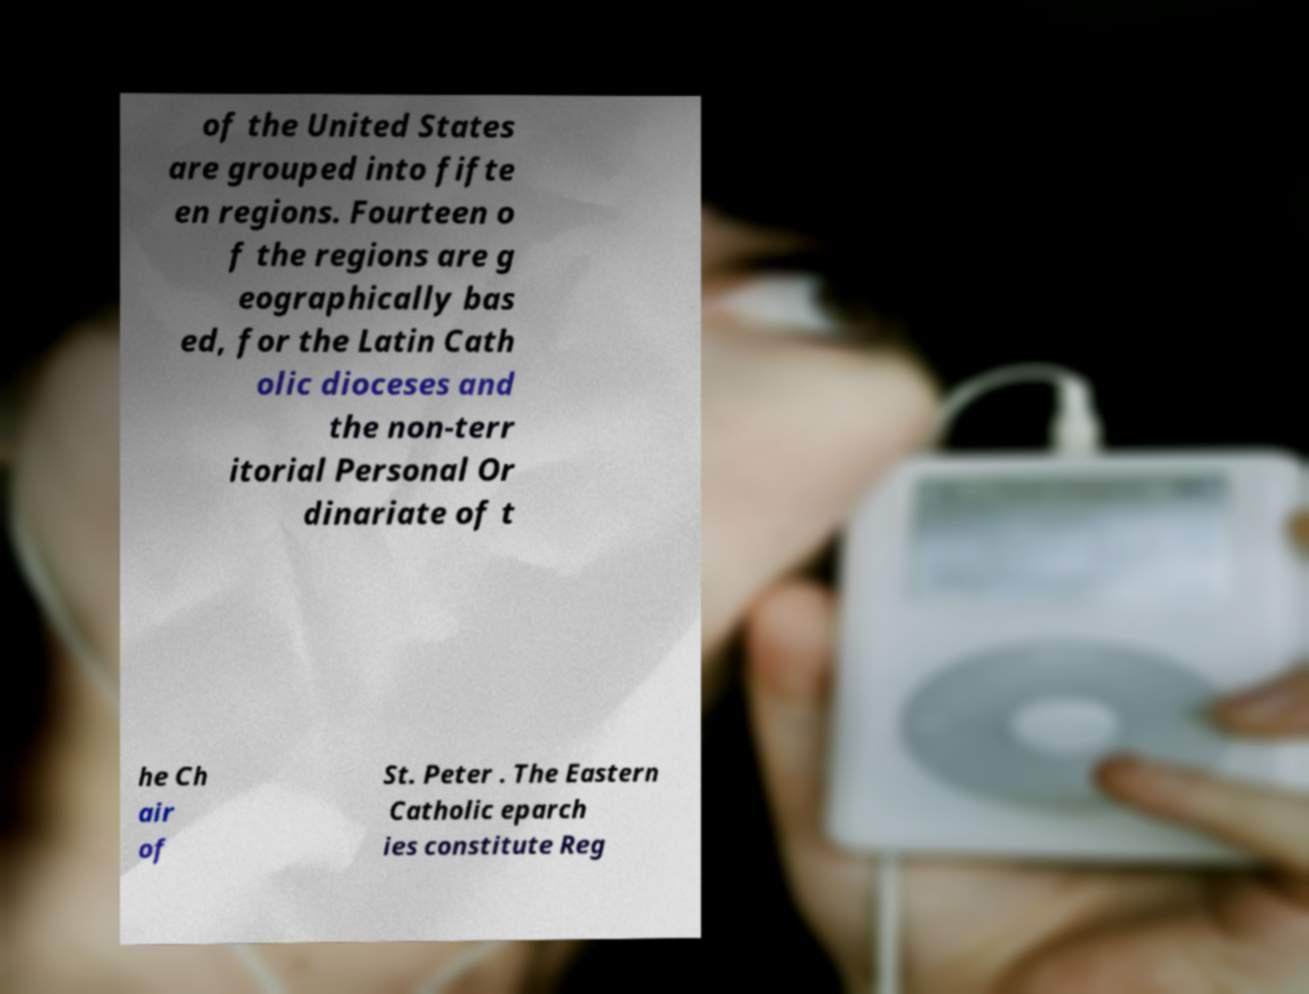What messages or text are displayed in this image? I need them in a readable, typed format. of the United States are grouped into fifte en regions. Fourteen o f the regions are g eographically bas ed, for the Latin Cath olic dioceses and the non-terr itorial Personal Or dinariate of t he Ch air of St. Peter . The Eastern Catholic eparch ies constitute Reg 